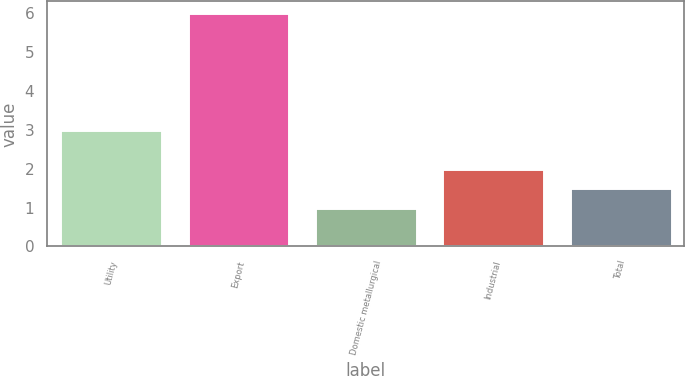Convert chart. <chart><loc_0><loc_0><loc_500><loc_500><bar_chart><fcel>Utility<fcel>Export<fcel>Domestic metallurgical<fcel>Industrial<fcel>Total<nl><fcel>3<fcel>6<fcel>1<fcel>2<fcel>1.5<nl></chart> 